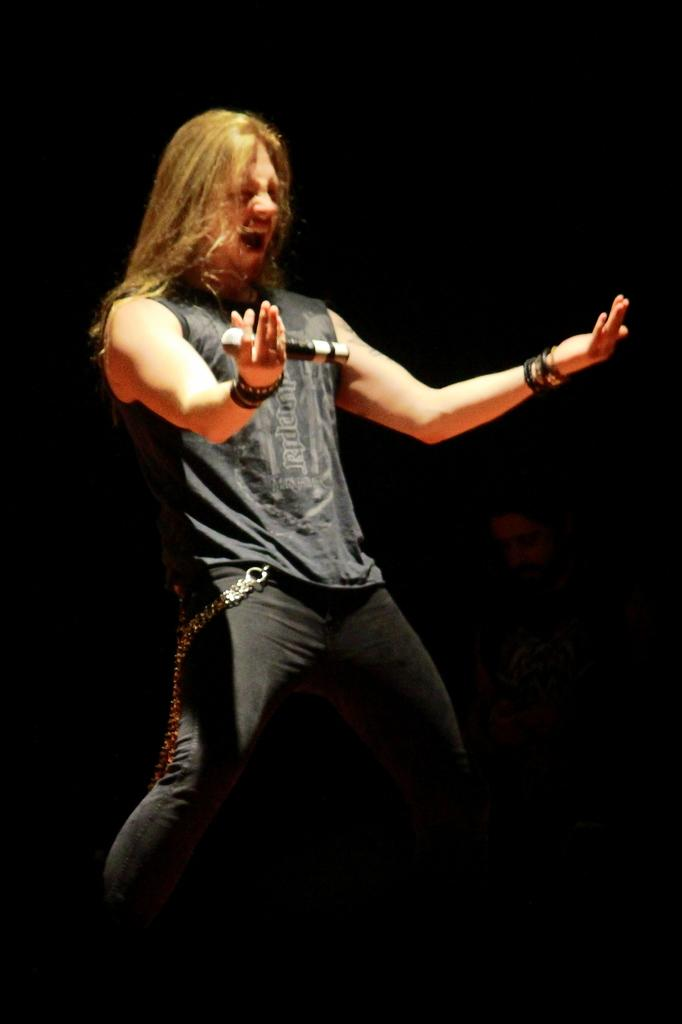Who is the main subject in the foreground of the image? There is a man in the foreground of the image. What is the man doing in the image? The man is standing and holding a mic in his hand. What can be observed about the background of the image? The background of the image is dark. What type of dinner is the man preparing in the image? There is no indication of dinner preparation in the image; the man is holding a mic. Can you tell me how many dolls are present in the image? There are no dolls present in the image. 